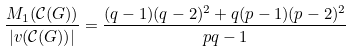<formula> <loc_0><loc_0><loc_500><loc_500>\frac { M _ { 1 } ( \mathcal { C } ( G ) ) } { | v ( \mathcal { C } ( G ) ) | } = \frac { ( q - 1 ) ( q - 2 ) ^ { 2 } + q ( p - 1 ) ( p - 2 ) ^ { 2 } } { p q - 1 }</formula> 